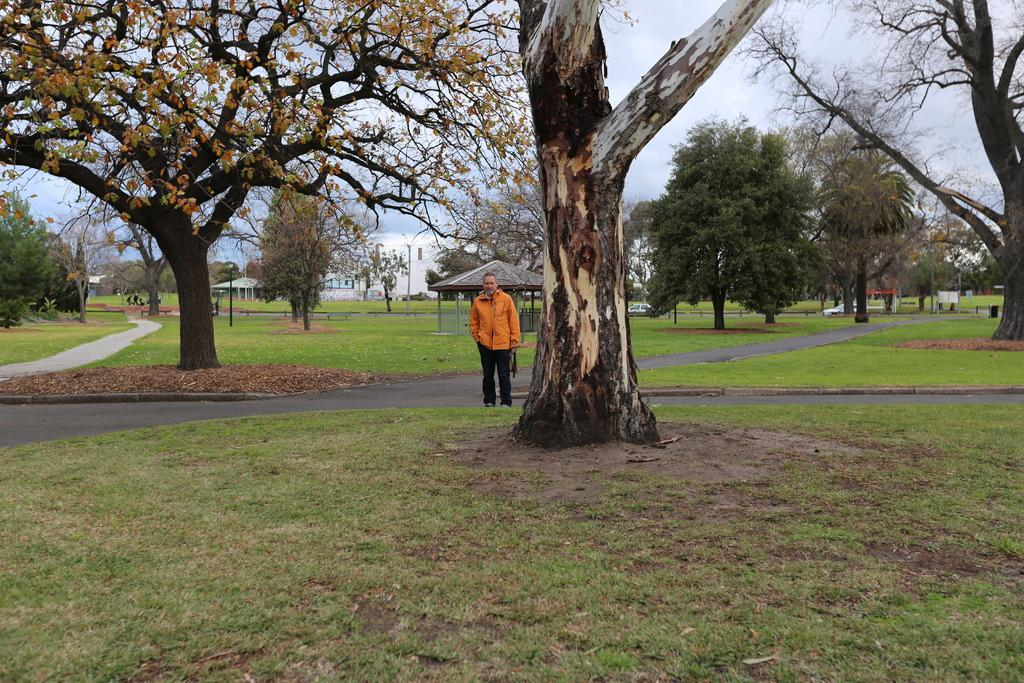What type of vegetation is present in the image? There are trees and grass in the image. What is the person in the image doing? The person is standing in front of a shelter. What is the person wearing in the image? The person is wearing clothes. What type of canvas is visible in the image? There is no canvas present in the image. Is there a river flowing through the image? No, there is no river visible in the image. 